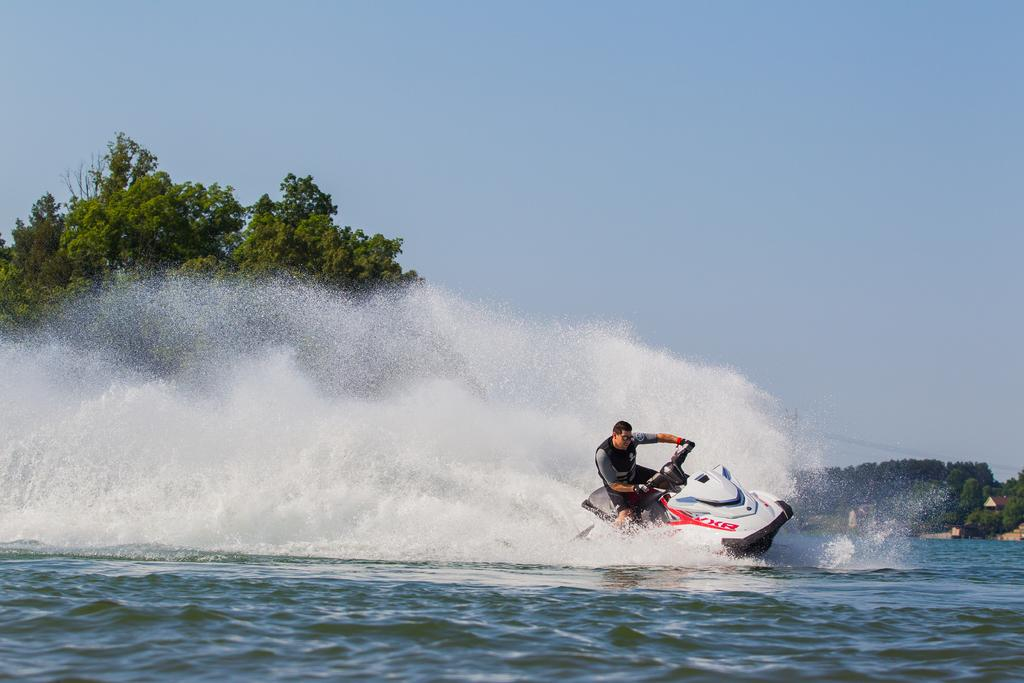What activity is the person in the image engaged in? The person is riding a jet ski in the image. Where is the jet ski located? The jet ski is on the water. What can be seen in the background of the image? There are trees and sky visible in the background of the image. Can you describe any other objects in the background of the image? There are some unspecified objects in the background of the image. What type of cheese is being used to make the stew in the image? There is no stew or cheese present in the image; it features a person riding a jet ski on the water. 